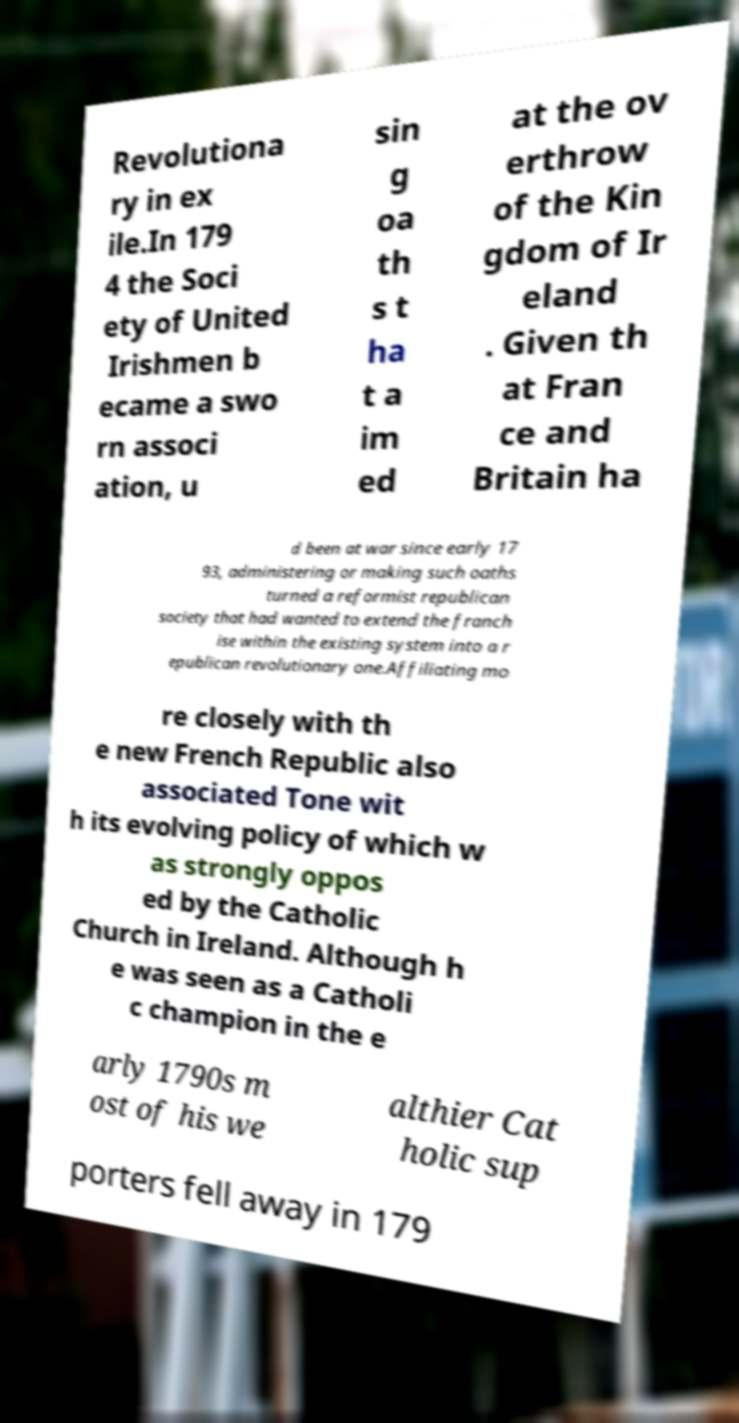Please identify and transcribe the text found in this image. Revolutiona ry in ex ile.In 179 4 the Soci ety of United Irishmen b ecame a swo rn associ ation, u sin g oa th s t ha t a im ed at the ov erthrow of the Kin gdom of Ir eland . Given th at Fran ce and Britain ha d been at war since early 17 93, administering or making such oaths turned a reformist republican society that had wanted to extend the franch ise within the existing system into a r epublican revolutionary one.Affiliating mo re closely with th e new French Republic also associated Tone wit h its evolving policy of which w as strongly oppos ed by the Catholic Church in Ireland. Although h e was seen as a Catholi c champion in the e arly 1790s m ost of his we althier Cat holic sup porters fell away in 179 